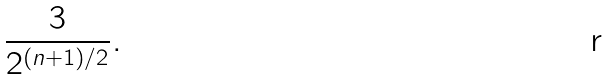<formula> <loc_0><loc_0><loc_500><loc_500>\frac { 3 } { 2 ^ { ( n + 1 ) / 2 } } .</formula> 